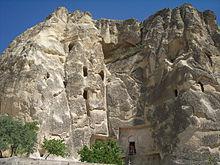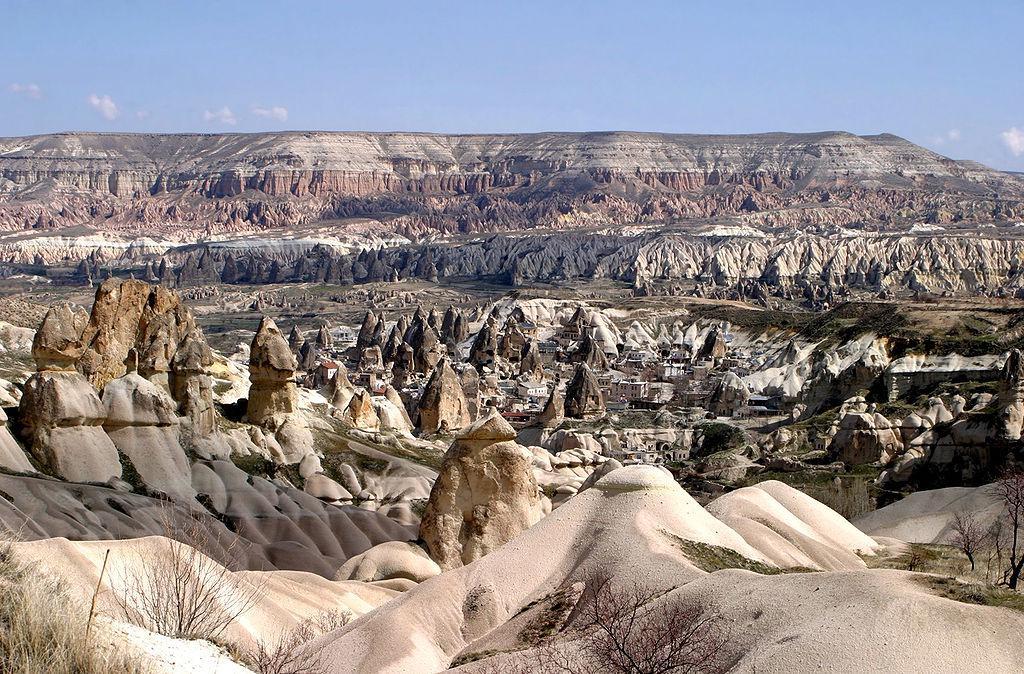The first image is the image on the left, the second image is the image on the right. For the images shown, is this caption "In at least one image there is a single large cloud over at least seven triangle rock structures." true? Answer yes or no. No. 